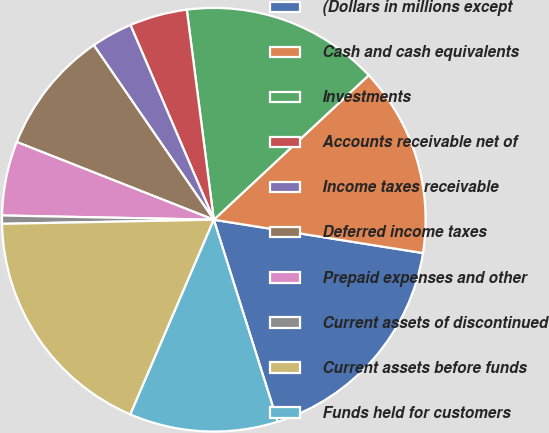Convert chart. <chart><loc_0><loc_0><loc_500><loc_500><pie_chart><fcel>(Dollars in millions except<fcel>Cash and cash equivalents<fcel>Investments<fcel>Accounts receivable net of<fcel>Income taxes receivable<fcel>Deferred income taxes<fcel>Prepaid expenses and other<fcel>Current assets of discontinued<fcel>Current assets before funds<fcel>Funds held for customers<nl><fcel>17.61%<fcel>14.46%<fcel>15.09%<fcel>4.4%<fcel>3.15%<fcel>9.43%<fcel>5.66%<fcel>0.63%<fcel>18.24%<fcel>11.32%<nl></chart> 